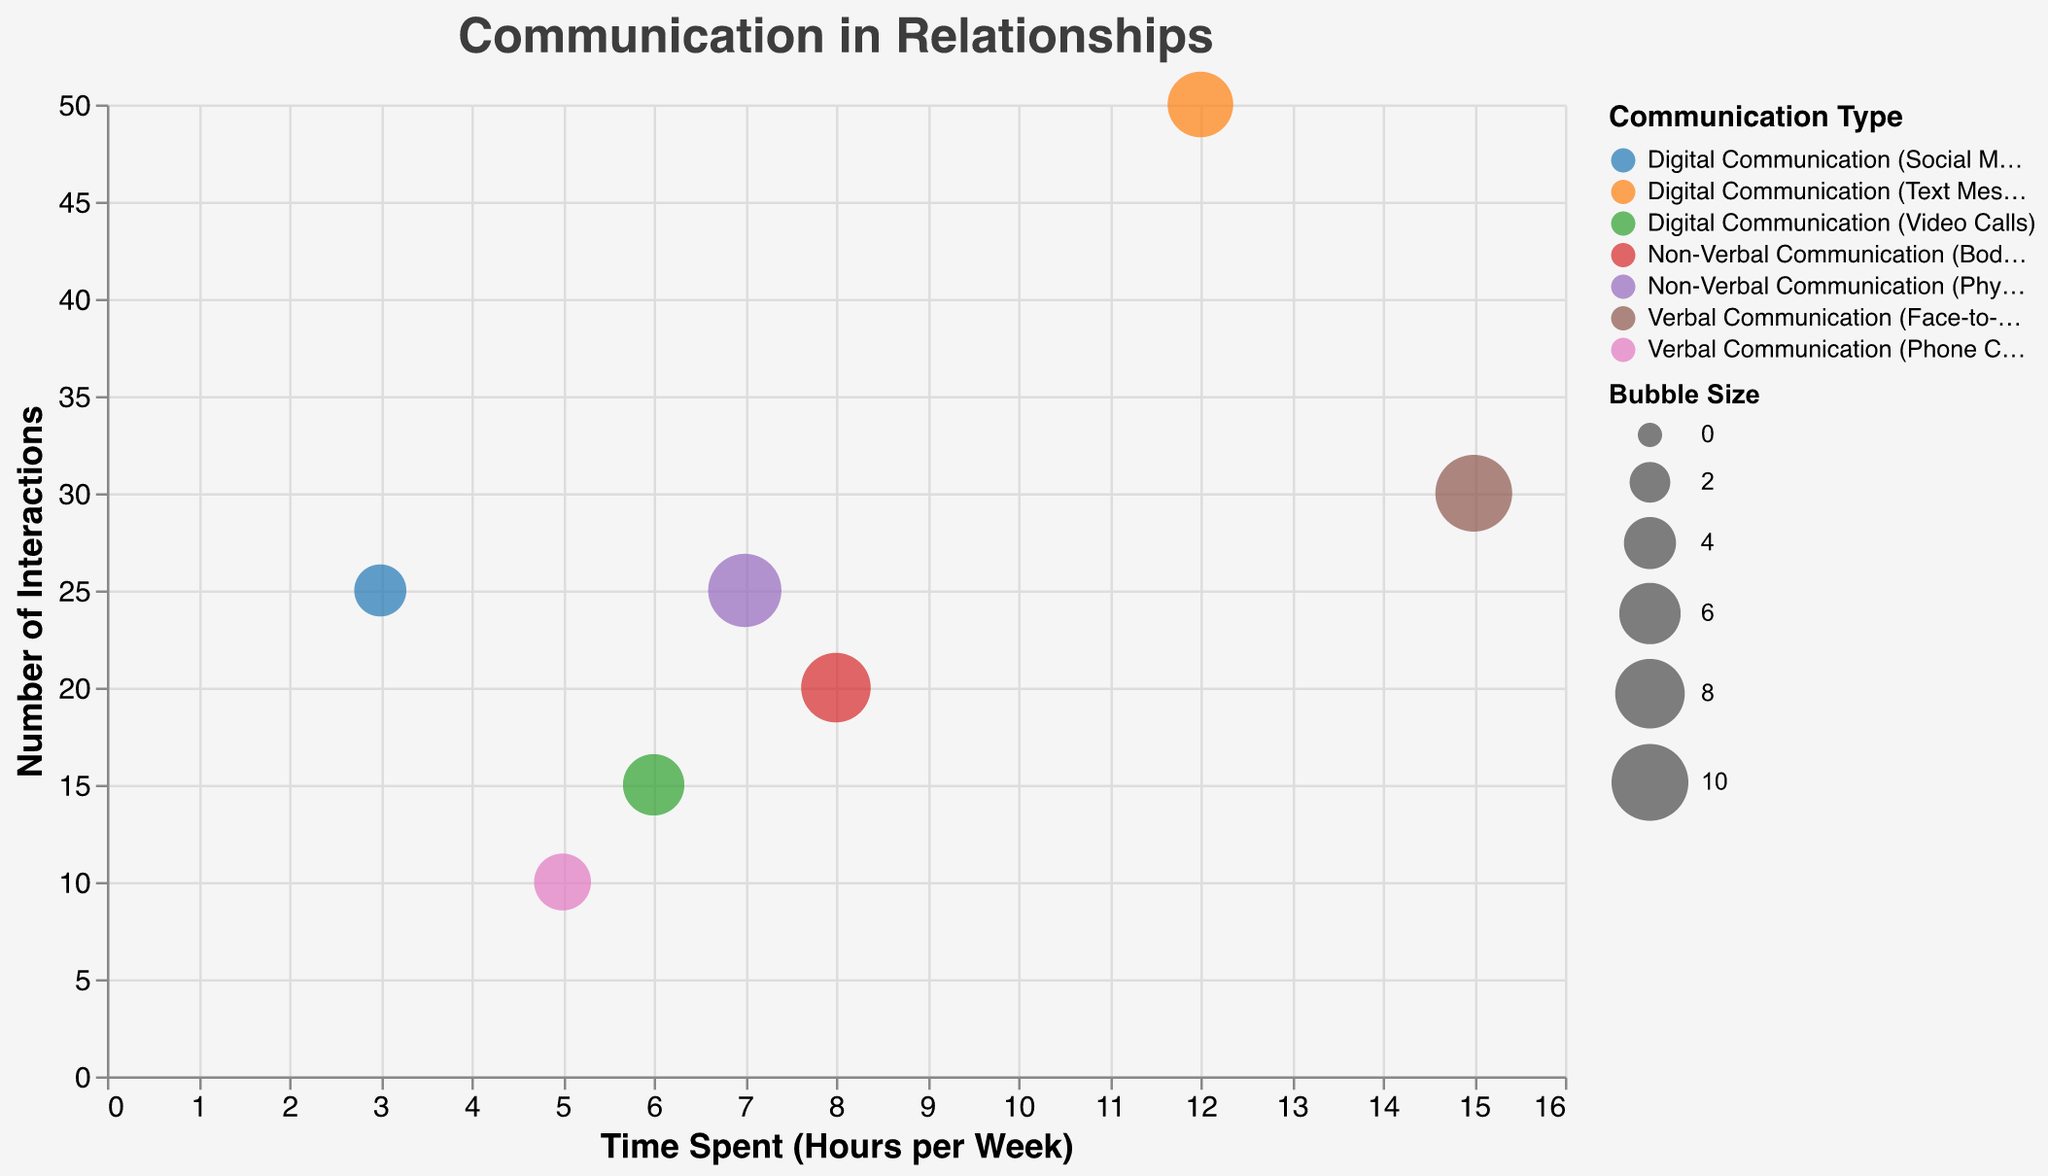What is the title of the figure? The title of the figure is located at the top center of the chart and is written in a large font.
Answer: Communication in Relationships How many different types of communication are represented in the chart? We count the number of unique bubbles, each representing a different type of communication.
Answer: 7 Which type of communication has the highest number of interactions? Look for the bubble positioned highest on the y-axis, which represents the number of interactions.
Answer: Digital Communication (Text Messaging) What is the total time spent on all forms of verbal communication in a week? Sum the time spent on "Verbal Communication (Face-to-Face)" and "Verbal Communication (Phone Calls)" from the x-axis values. 15 (Face-to-Face) + 5 (Phone Calls) = 20 hours
Answer: 20 hours Which type of communication has the largest bubble size? Identify the largest bubble by visual inspection.
Answer: Verbal Communication (Face-to-Face) Between non-verbal and digital communication, which has more time spent per week on average? Calculate the average time by summing the time spent on non-verbal communication and digital communication, then dividing each by the number of respective types. Non-verbal: (8 + 7) / 2 = 7.5 hours, Digital: (12 + 6 + 3) / 3 = 7 hours. Compare the two averages.
Answer: Non-Verbal Communication How much more time is spent on face-to-face communication compared to video calls? Subtract the time spent on "Digital Communication (Video Calls)" from "Verbal Communication (Face-to-Face)." 15 - 6 = 9 hours
Answer: 9 hours What is the difference in the number of interactions between physical touch and social media? Subtract the number of interactions for "Digital Communication (Social Media)" from "Non-Verbal Communication (Physical Touch)." 25 - 25 = 0 interactions
Answer: 0 interactions Which communication type shows a balance between medium time spent and high interactions? Identify a bubble that is roughly in the middle of the x-axis (time spent) but higher on the y-axis (number of interactions).
Answer: Non-Verbal Communication (Physical Touch) What is a unique feature of the bubble chart used here? Look at the visual style and characteristics of the bubbles, and describe a distinctive element.
Answer: Transparent Bubbles 